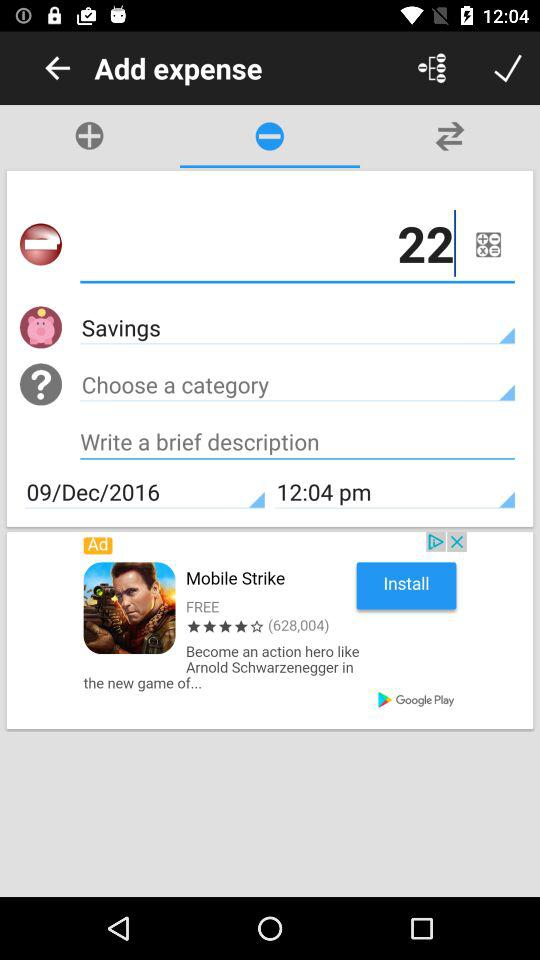What is the date? The date is December 9, 2016. 